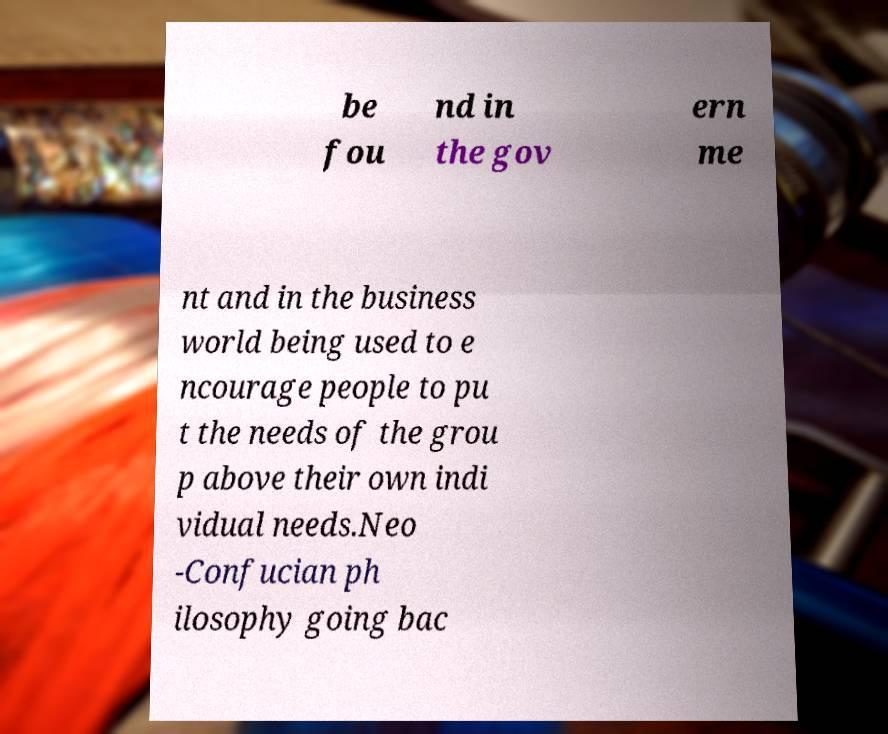Could you extract and type out the text from this image? be fou nd in the gov ern me nt and in the business world being used to e ncourage people to pu t the needs of the grou p above their own indi vidual needs.Neo -Confucian ph ilosophy going bac 